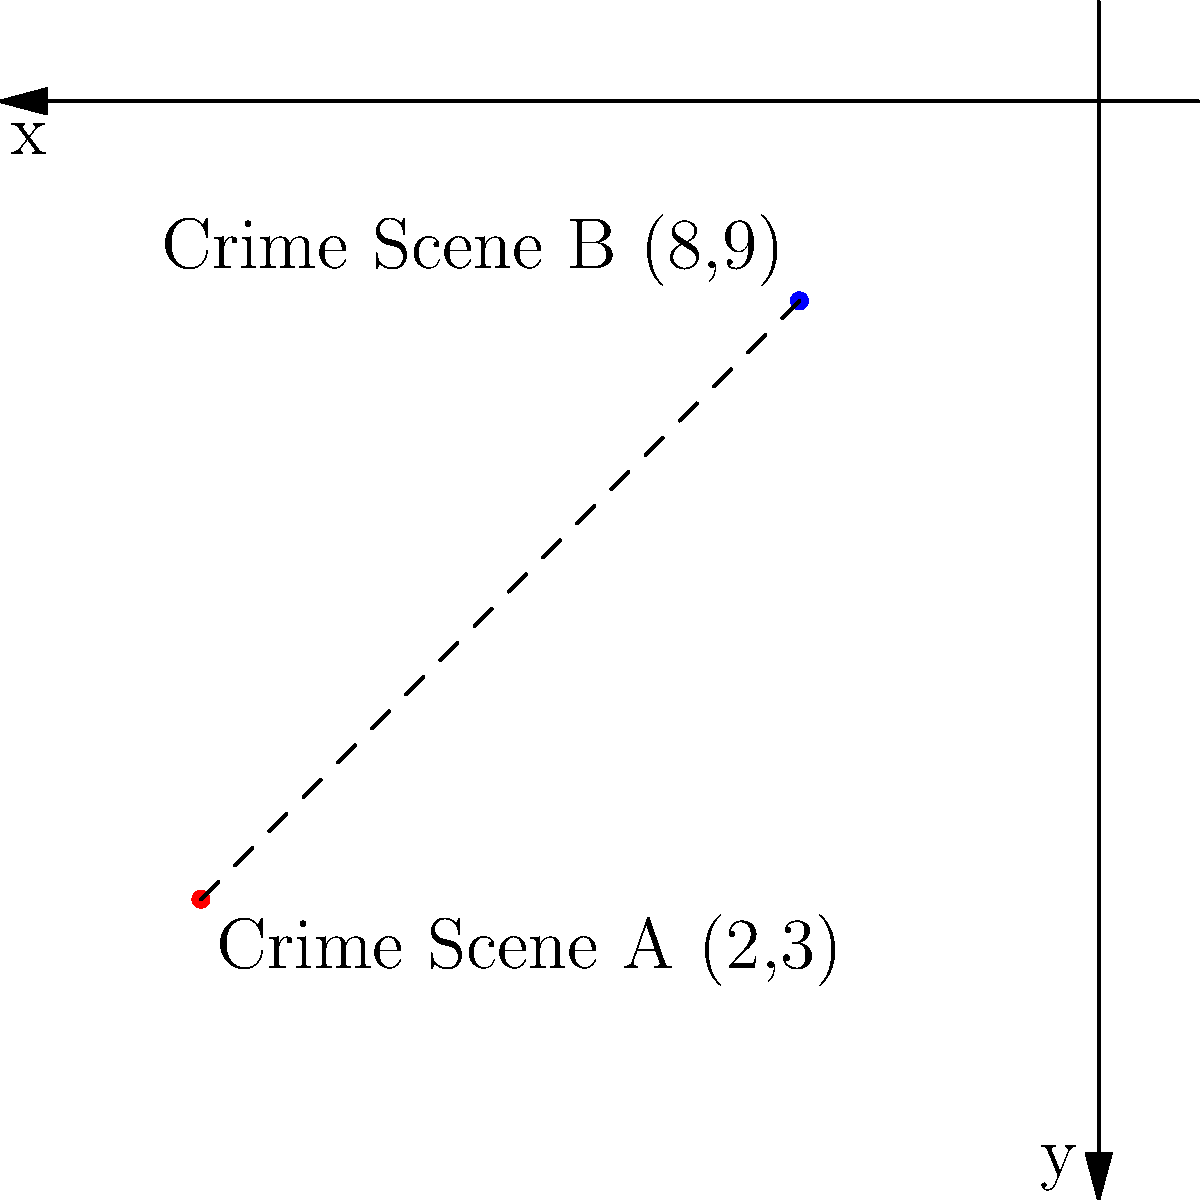Two crime scenes have been identified in a city grid system. Crime Scene A is located at coordinates (2,3), and Crime Scene B is at (8,9). As an FBI agent, you need to calculate the straight-line distance between these two crime scenes. Using the distance formula, determine the distance between Crime Scene A and Crime Scene B to the nearest tenth of a unit. To solve this problem, we'll use the distance formula derived from the Pythagorean theorem:

$$d = \sqrt{(x_2-x_1)^2 + (y_2-y_1)^2}$$

Where $(x_1,y_1)$ is the coordinate of the first point and $(x_2,y_2)$ is the coordinate of the second point.

Step 1: Identify the coordinates
- Crime Scene A: $(x_1,y_1) = (2,3)$
- Crime Scene B: $(x_2,y_2) = (8,9)$

Step 2: Plug the coordinates into the distance formula
$$d = \sqrt{(8-2)^2 + (9-3)^2}$$

Step 3: Simplify the expressions inside the parentheses
$$d = \sqrt{6^2 + 6^2}$$

Step 4: Calculate the squares
$$d = \sqrt{36 + 36}$$

Step 5: Add the values under the square root
$$d = \sqrt{72}$$

Step 6: Simplify the square root
$$d = 6\sqrt{2}$$

Step 7: Use a calculator to approximate the result and round to the nearest tenth
$$d \approx 8.5$$

Therefore, the distance between Crime Scene A and Crime Scene B is approximately 8.5 units.
Answer: 8.5 units 